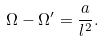<formula> <loc_0><loc_0><loc_500><loc_500>\Omega - \Omega ^ { \prime } = \frac { a } { l ^ { 2 } } .</formula> 